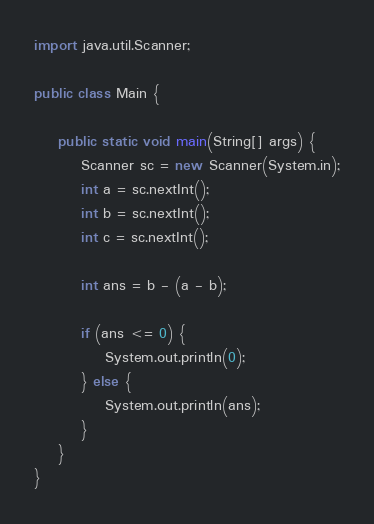Convert code to text. <code><loc_0><loc_0><loc_500><loc_500><_Java_>
import java.util.Scanner;

public class Main {

	public static void main(String[] args) {
		Scanner sc = new Scanner(System.in);
		int a = sc.nextInt();
		int b = sc.nextInt();
		int c = sc.nextInt();

		int ans = b - (a - b);

		if (ans <= 0) {
			System.out.println(0);
		} else {
			System.out.println(ans);
		}
	}
}</code> 